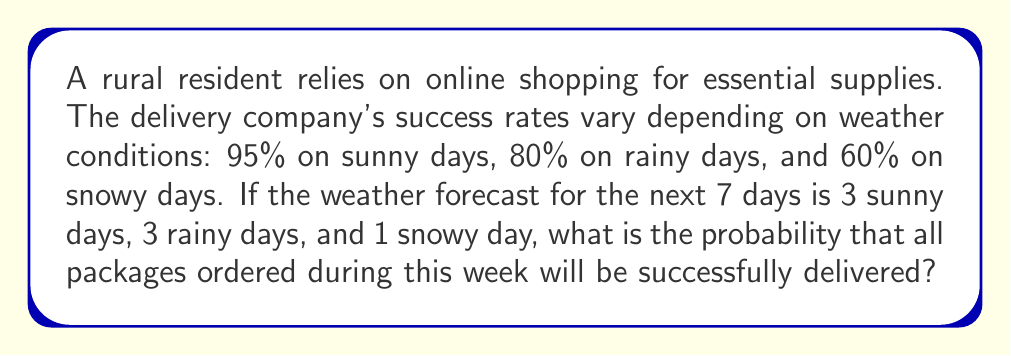Could you help me with this problem? Let's approach this step-by-step:

1) For a package to be delivered successfully on a given day, we multiply the probabilities:
   Sunny day: $0.95$
   Rainy day: $0.80$
   Snowy day: $0.60$

2) For all packages to be delivered successfully over the week, we need successful delivery on all 7 days. This means we multiply the probabilities for each day:

   $P(\text{all successful}) = 0.95^3 \times 0.80^3 \times 0.60^1$

3) Let's calculate this:
   
   $0.95^3 = 0.857375$
   $0.80^3 = 0.512$
   $0.60^1 = 0.60$

4) Multiplying these together:

   $P(\text{all successful}) = 0.857375 \times 0.512 \times 0.60$
                              $= 0.263381$

5) Converting to a percentage:

   $0.263381 \times 100\% = 26.3381\%$

Therefore, the probability that all packages ordered during this week will be successfully delivered is approximately 26.34%.
Answer: $26.34\%$ 